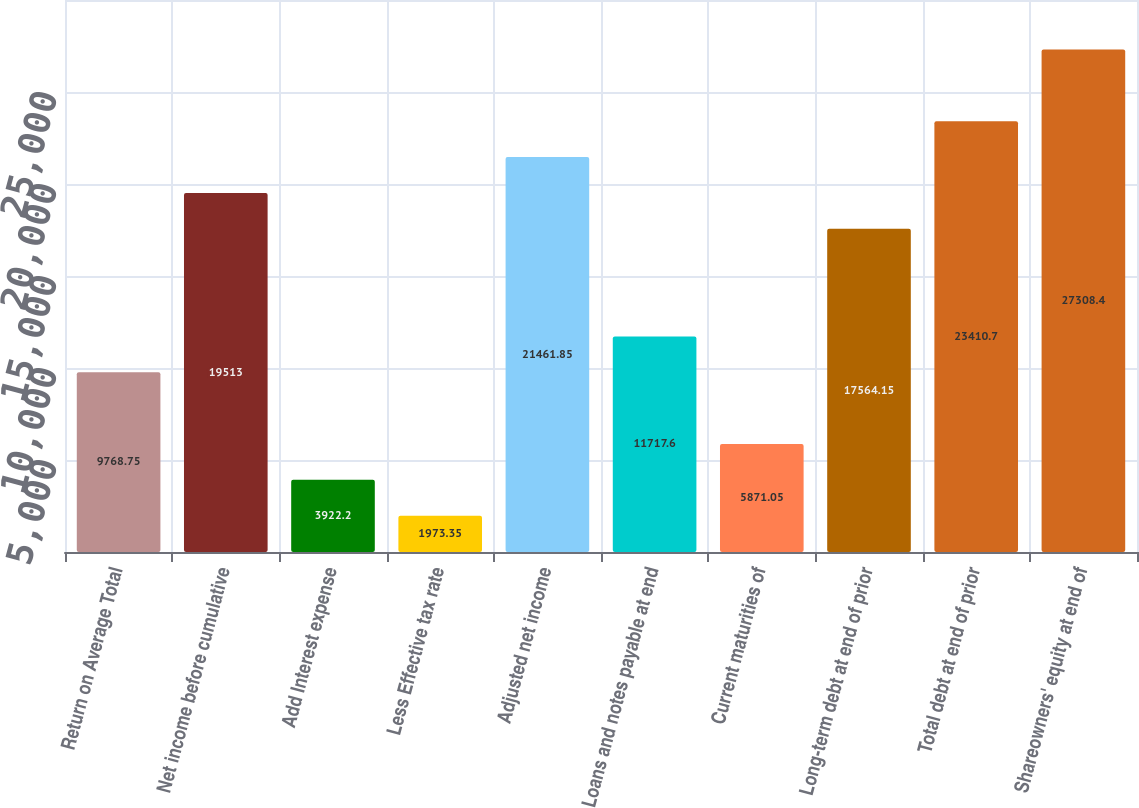Convert chart. <chart><loc_0><loc_0><loc_500><loc_500><bar_chart><fcel>Return on Average Total<fcel>Net income before cumulative<fcel>Add Interest expense<fcel>Less Effective tax rate<fcel>Adjusted net income<fcel>Loans and notes payable at end<fcel>Current maturities of<fcel>Long-term debt at end of prior<fcel>Total debt at end of prior<fcel>Shareowners' equity at end of<nl><fcel>9768.75<fcel>19513<fcel>3922.2<fcel>1973.35<fcel>21461.8<fcel>11717.6<fcel>5871.05<fcel>17564.2<fcel>23410.7<fcel>27308.4<nl></chart> 